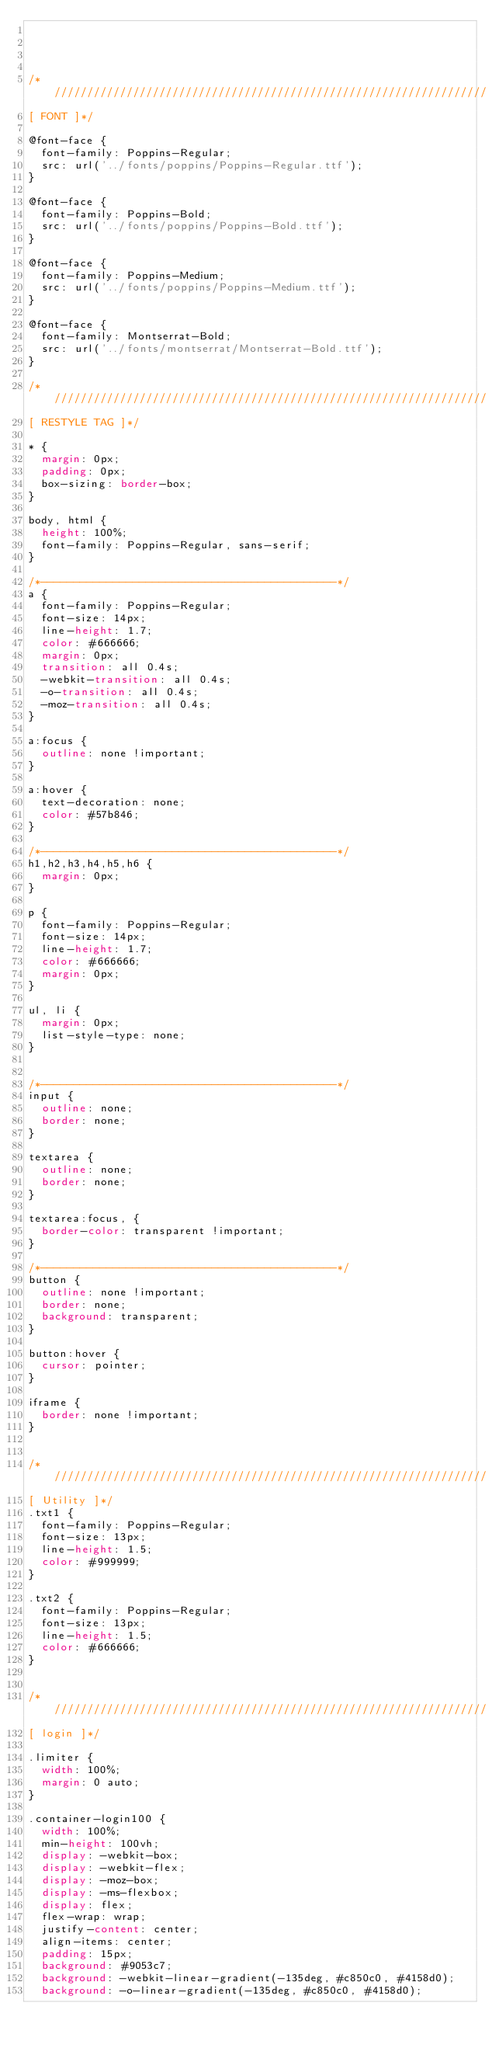Convert code to text. <code><loc_0><loc_0><loc_500><loc_500><_CSS_>



/*//////////////////////////////////////////////////////////////////
[ FONT ]*/

@font-face {
  font-family: Poppins-Regular;
  src: url('../fonts/poppins/Poppins-Regular.ttf'); 
}

@font-face {
  font-family: Poppins-Bold;
  src: url('../fonts/poppins/Poppins-Bold.ttf'); 
}

@font-face {
  font-family: Poppins-Medium;
  src: url('../fonts/poppins/Poppins-Medium.ttf'); 
}

@font-face {
  font-family: Montserrat-Bold;
  src: url('../fonts/montserrat/Montserrat-Bold.ttf'); 
}

/*//////////////////////////////////////////////////////////////////
[ RESTYLE TAG ]*/

* {
	margin: 0px; 
	padding: 0px; 
	box-sizing: border-box;
}

body, html {
	height: 100%;
	font-family: Poppins-Regular, sans-serif;
}

/*---------------------------------------------*/
a {
	font-family: Poppins-Regular;
	font-size: 14px;
	line-height: 1.7;
	color: #666666;
	margin: 0px;
	transition: all 0.4s;
	-webkit-transition: all 0.4s;
  -o-transition: all 0.4s;
  -moz-transition: all 0.4s;
}

a:focus {
	outline: none !important;
}

a:hover {
	text-decoration: none;
  color: #57b846;
}

/*---------------------------------------------*/
h1,h2,h3,h4,h5,h6 {
	margin: 0px;
}

p {
	font-family: Poppins-Regular;
	font-size: 14px;
	line-height: 1.7;
	color: #666666;
	margin: 0px;
}

ul, li {
	margin: 0px;
	list-style-type: none;
}


/*---------------------------------------------*/
input {
	outline: none;
	border: none;
}

textarea {
  outline: none;
  border: none;
}

textarea:focus, {
  border-color: transparent !important;
}

/*---------------------------------------------*/
button {
	outline: none !important;
	border: none;
	background: transparent;
}

button:hover {
	cursor: pointer;
}

iframe {
	border: none !important;
}


/*//////////////////////////////////////////////////////////////////
[ Utility ]*/
.txt1 {
  font-family: Poppins-Regular;
  font-size: 13px;
  line-height: 1.5;
  color: #999999;
}

.txt2 {
  font-family: Poppins-Regular;
  font-size: 13px;
  line-height: 1.5;
  color: #666666;
}


/*//////////////////////////////////////////////////////////////////
[ login ]*/

.limiter {
  width: 100%;
  margin: 0 auto;
}

.container-login100 {
  width: 100%;  
  min-height: 100vh;
  display: -webkit-box;
  display: -webkit-flex;
  display: -moz-box;
  display: -ms-flexbox;
  display: flex;
  flex-wrap: wrap;
  justify-content: center;
  align-items: center;
  padding: 15px;
  background: #9053c7;
  background: -webkit-linear-gradient(-135deg, #c850c0, #4158d0);
  background: -o-linear-gradient(-135deg, #c850c0, #4158d0);</code> 